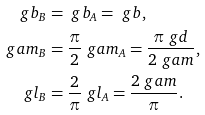Convert formula to latex. <formula><loc_0><loc_0><loc_500><loc_500>\ g b _ { B } & = \ g b _ { A } = \ g b , \\ \ g a m _ { B } & = \frac { \pi } 2 \ g a m _ { A } = \frac { \pi \ g d } { 2 \ g a m } , \\ \ g l _ { B } & = \frac { 2 } { \pi } \ g l _ { A } = \frac { 2 \ g a m } \pi .</formula> 